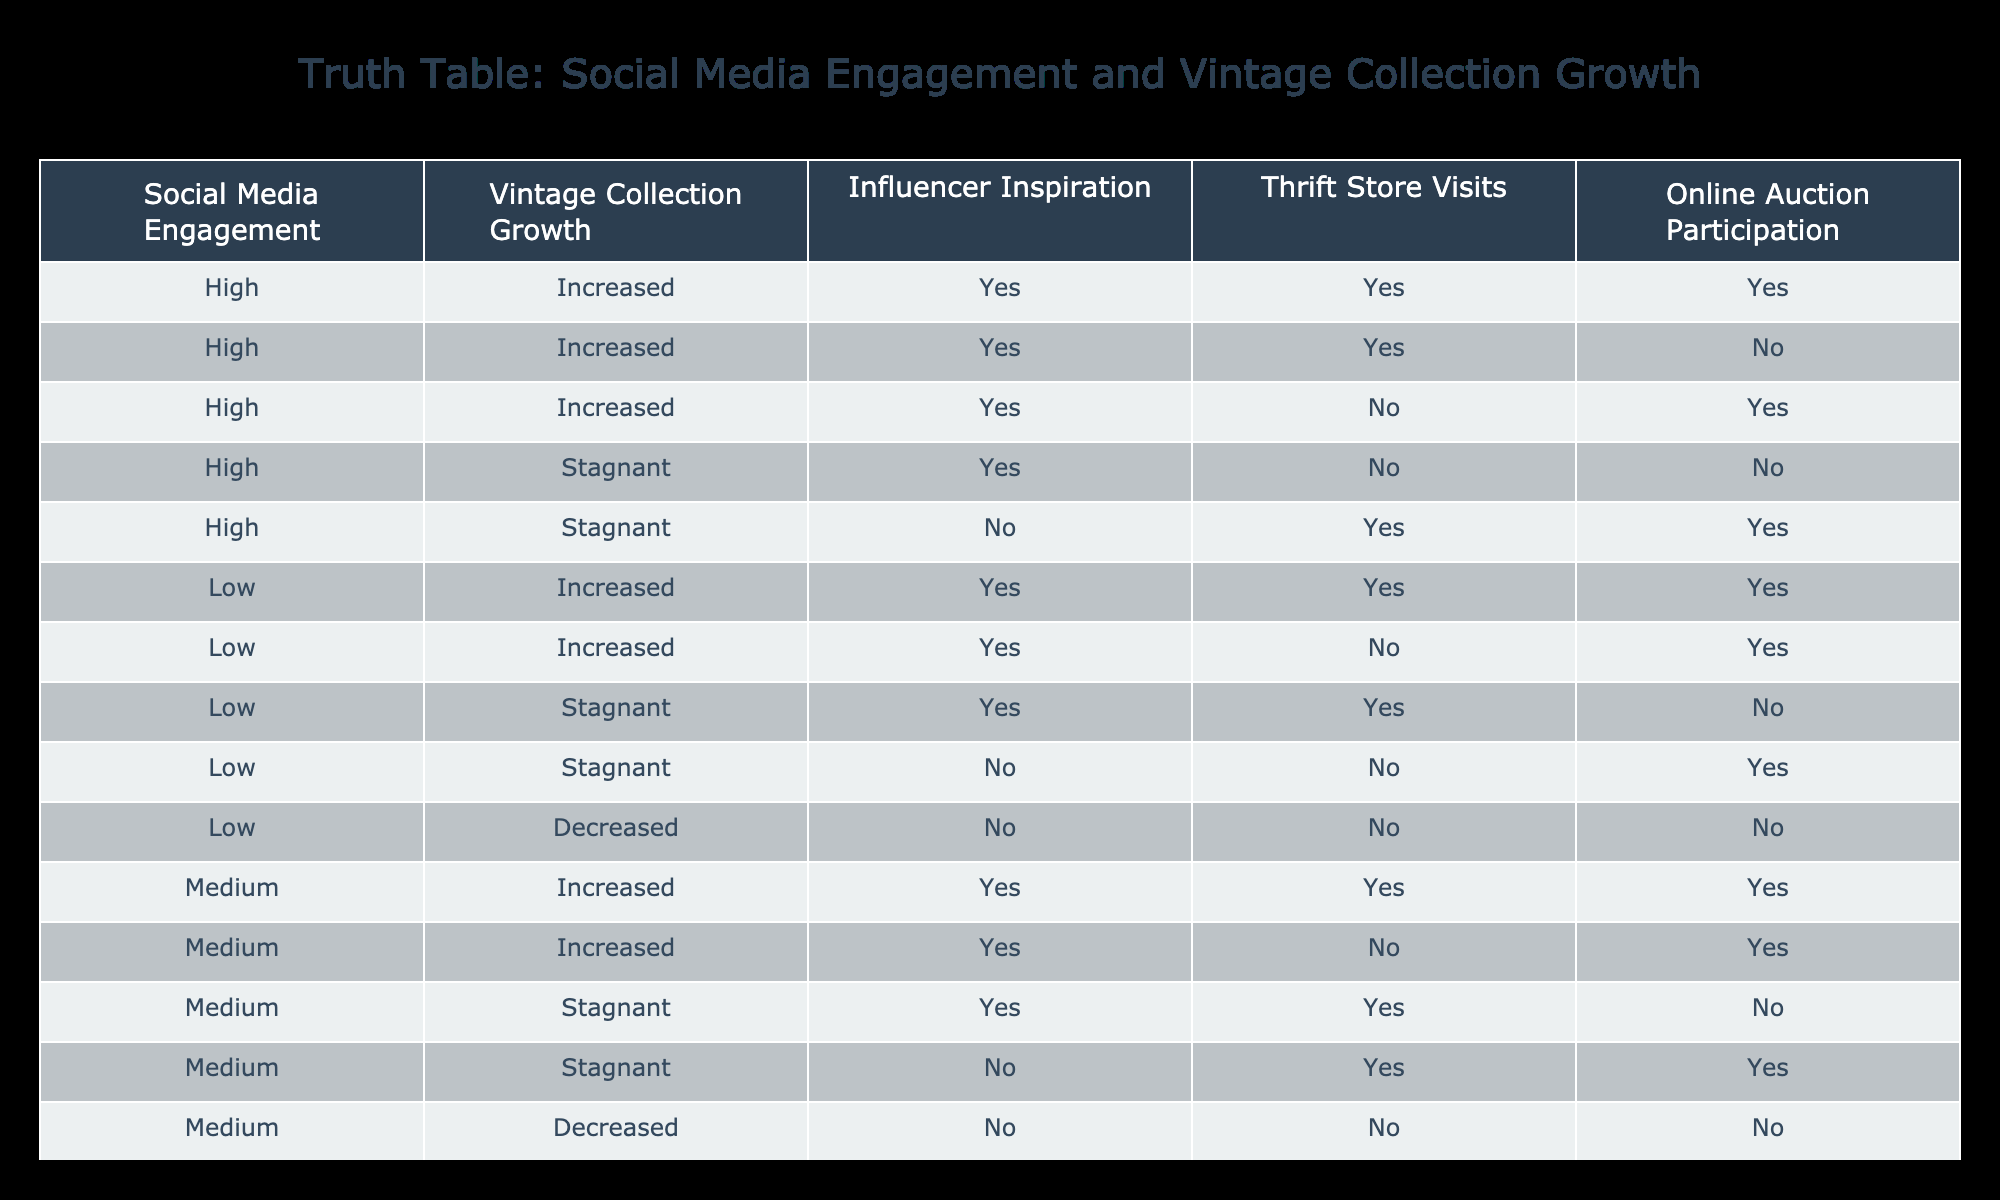What percentage of cases show increased vintage collection growth when social media engagement is high? There are 3 cases with high engagement and increased vintage growth out of a total of 5 cases with high engagement. So, the percentage is (3/5) * 100 = 60%.
Answer: 60% What is the relationship between influencer inspiration and thrift store visits for cases with stagnant vintage collection growth? There are 2 cases of stagnant growth. One has "influencer inspiration" as Yes and "thrift store visits" as Yes, while the other has them both as No. This shows no cases with Yes for both factors contributing to stagnant growth.
Answer: No cases show this relationship How many cases have low social media engagement but still showed increased vintage collection growth? There are 3 cases where low engagement resulted in increased vintage collection growth (the first two rows under low engagement).
Answer: 3 Is there any combination that leads to both "online auction participation" and "vintage collection growth"? Yes, there are cases showing both "online auction participation" as Yes and "vintage collection growth" as Increased; specifically, there are a total of 4 such cases in the table.
Answer: Yes Among the cases with medium social media engagement, how many resulted in decreased vintage collection growth? There are 1 case with medium engagement and decreased growth. The two other rows with this engagement had stagnant growth.
Answer: 1 